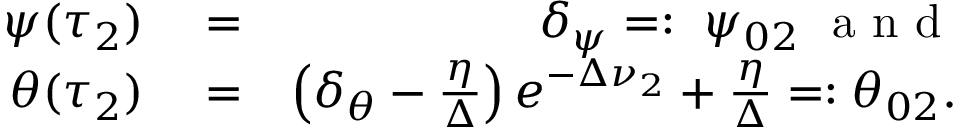<formula> <loc_0><loc_0><loc_500><loc_500>\begin{array} { r l r } { \psi ( \tau _ { 2 } ) } & = } & { \delta _ { \psi } = \colon \ \psi _ { 0 2 } a n d } \\ { \theta ( \tau _ { 2 } ) } & = } & { \left ( \delta _ { \theta } - \frac { \eta } { \Delta } \right ) e ^ { - \Delta \nu _ { 2 } } + \frac { \eta } { \Delta } = \colon \theta _ { 0 2 } . } \end{array}</formula> 